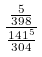Convert formula to latex. <formula><loc_0><loc_0><loc_500><loc_500>\frac { \frac { 5 } { 3 9 8 } } { \frac { 1 4 1 ^ { 5 } } { 3 0 4 } }</formula> 